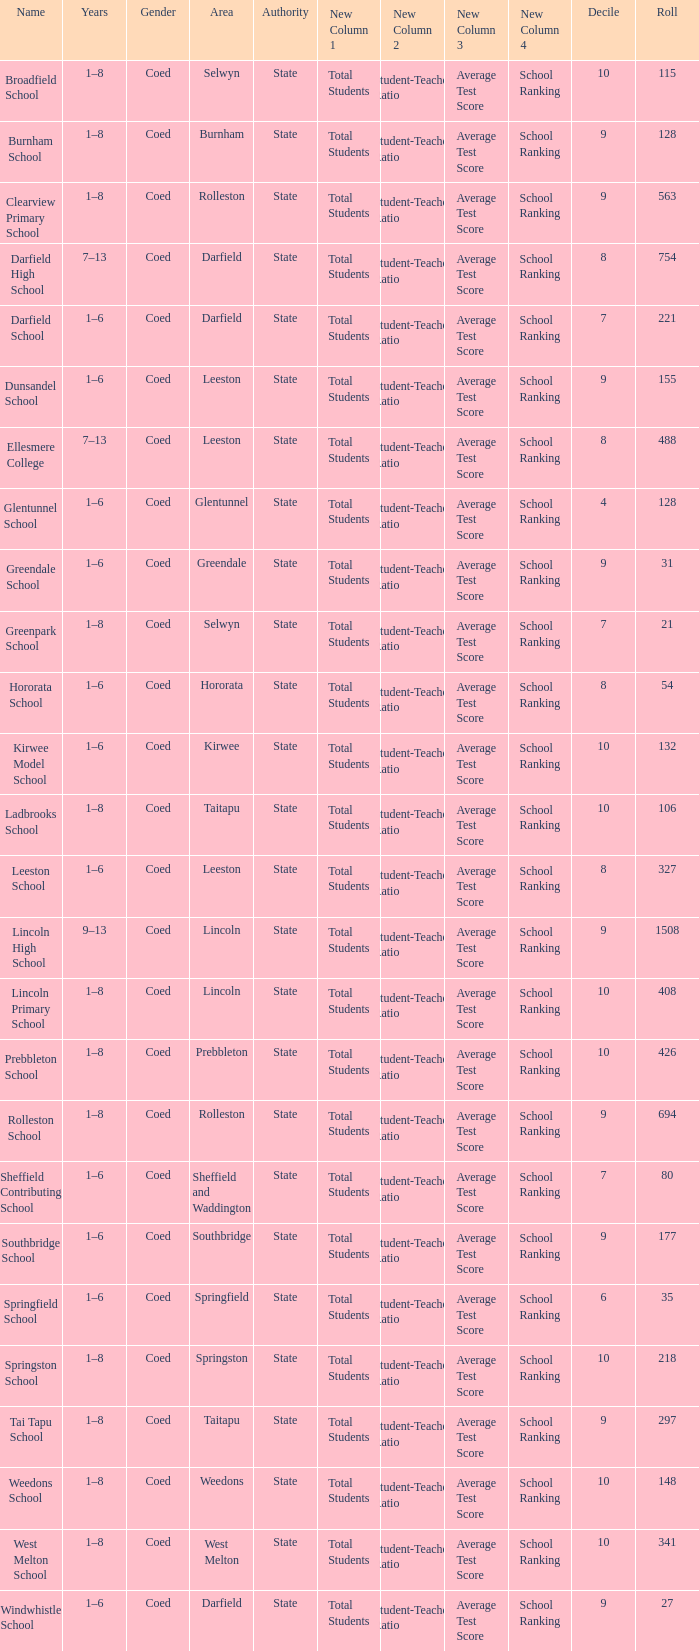Give me the full table as a dictionary. {'header': ['Name', 'Years', 'Gender', 'Area', 'Authority', 'New Column 1', 'New Column 2', 'New Column 3', 'New Column 4', 'Decile', 'Roll'], 'rows': [['Broadfield School', '1–8', 'Coed', 'Selwyn', 'State', 'Total Students', 'Student-Teacher Ratio', 'Average Test Score', 'School Ranking', '10', '115'], ['Burnham School', '1–8', 'Coed', 'Burnham', 'State', 'Total Students', 'Student-Teacher Ratio', 'Average Test Score', 'School Ranking', '9', '128'], ['Clearview Primary School', '1–8', 'Coed', 'Rolleston', 'State', 'Total Students', 'Student-Teacher Ratio', 'Average Test Score', 'School Ranking', '9', '563'], ['Darfield High School', '7–13', 'Coed', 'Darfield', 'State', 'Total Students', 'Student-Teacher Ratio', 'Average Test Score', 'School Ranking', '8', '754'], ['Darfield School', '1–6', 'Coed', 'Darfield', 'State', 'Total Students', 'Student-Teacher Ratio', 'Average Test Score', 'School Ranking', '7', '221'], ['Dunsandel School', '1–6', 'Coed', 'Leeston', 'State', 'Total Students', 'Student-Teacher Ratio', 'Average Test Score', 'School Ranking', '9', '155'], ['Ellesmere College', '7–13', 'Coed', 'Leeston', 'State', 'Total Students', 'Student-Teacher Ratio', 'Average Test Score', 'School Ranking', '8', '488'], ['Glentunnel School', '1–6', 'Coed', 'Glentunnel', 'State', 'Total Students', 'Student-Teacher Ratio', 'Average Test Score', 'School Ranking', '4', '128'], ['Greendale School', '1–6', 'Coed', 'Greendale', 'State', 'Total Students', 'Student-Teacher Ratio', 'Average Test Score', 'School Ranking', '9', '31'], ['Greenpark School', '1–8', 'Coed', 'Selwyn', 'State', 'Total Students', 'Student-Teacher Ratio', 'Average Test Score', 'School Ranking', '7', '21'], ['Hororata School', '1–6', 'Coed', 'Hororata', 'State', 'Total Students', 'Student-Teacher Ratio', 'Average Test Score', 'School Ranking', '8', '54'], ['Kirwee Model School', '1–6', 'Coed', 'Kirwee', 'State', 'Total Students', 'Student-Teacher Ratio', 'Average Test Score', 'School Ranking', '10', '132'], ['Ladbrooks School', '1–8', 'Coed', 'Taitapu', 'State', 'Total Students', 'Student-Teacher Ratio', 'Average Test Score', 'School Ranking', '10', '106'], ['Leeston School', '1–6', 'Coed', 'Leeston', 'State', 'Total Students', 'Student-Teacher Ratio', 'Average Test Score', 'School Ranking', '8', '327'], ['Lincoln High School', '9–13', 'Coed', 'Lincoln', 'State', 'Total Students', 'Student-Teacher Ratio', 'Average Test Score', 'School Ranking', '9', '1508'], ['Lincoln Primary School', '1–8', 'Coed', 'Lincoln', 'State', 'Total Students', 'Student-Teacher Ratio', 'Average Test Score', 'School Ranking', '10', '408'], ['Prebbleton School', '1–8', 'Coed', 'Prebbleton', 'State', 'Total Students', 'Student-Teacher Ratio', 'Average Test Score', 'School Ranking', '10', '426'], ['Rolleston School', '1–8', 'Coed', 'Rolleston', 'State', 'Total Students', 'Student-Teacher Ratio', 'Average Test Score', 'School Ranking', '9', '694'], ['Sheffield Contributing School', '1–6', 'Coed', 'Sheffield and Waddington', 'State', 'Total Students', 'Student-Teacher Ratio', 'Average Test Score', 'School Ranking', '7', '80'], ['Southbridge School', '1–6', 'Coed', 'Southbridge', 'State', 'Total Students', 'Student-Teacher Ratio', 'Average Test Score', 'School Ranking', '9', '177'], ['Springfield School', '1–6', 'Coed', 'Springfield', 'State', 'Total Students', 'Student-Teacher Ratio', 'Average Test Score', 'School Ranking', '6', '35'], ['Springston School', '1–8', 'Coed', 'Springston', 'State', 'Total Students', 'Student-Teacher Ratio', 'Average Test Score', 'School Ranking', '10', '218'], ['Tai Tapu School', '1–8', 'Coed', 'Taitapu', 'State', 'Total Students', 'Student-Teacher Ratio', 'Average Test Score', 'School Ranking', '9', '297'], ['Weedons School', '1–8', 'Coed', 'Weedons', 'State', 'Total Students', 'Student-Teacher Ratio', 'Average Test Score', 'School Ranking', '10', '148'], ['West Melton School', '1–8', 'Coed', 'West Melton', 'State', 'Total Students', 'Student-Teacher Ratio', 'Average Test Score', 'School Ranking', '10', '341'], ['Windwhistle School', '1–6', 'Coed', 'Darfield', 'State', 'Total Students', 'Student-Teacher Ratio', 'Average Test Score', 'School Ranking', '9', '27']]} What is the name with a Decile less than 10, and a Roll of 297? Tai Tapu School. 